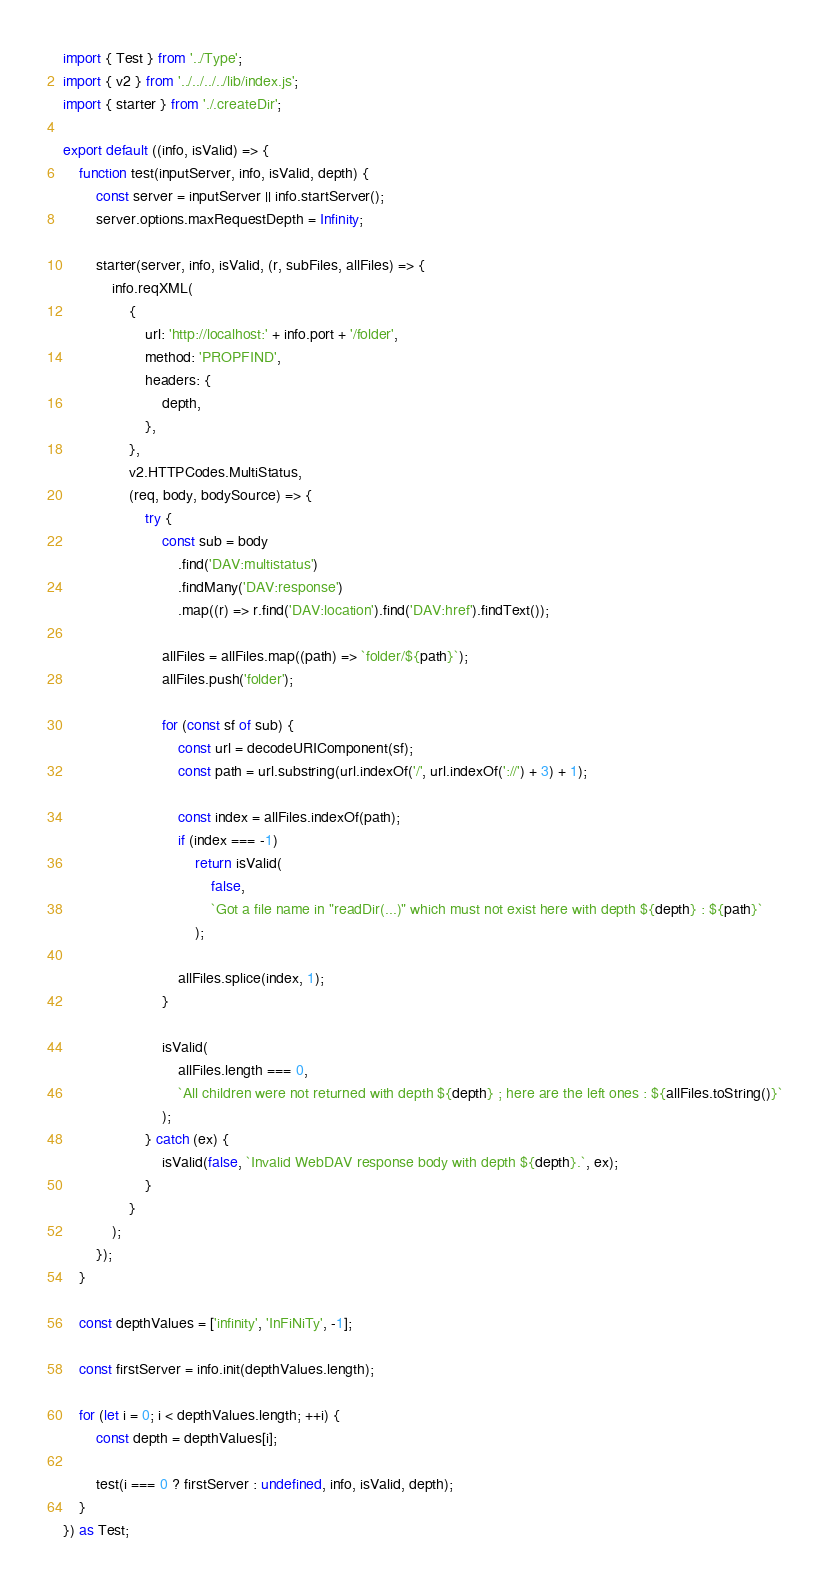Convert code to text. <code><loc_0><loc_0><loc_500><loc_500><_TypeScript_>import { Test } from '../Type';
import { v2 } from '../../../../lib/index.js';
import { starter } from './.createDir';

export default ((info, isValid) => {
	function test(inputServer, info, isValid, depth) {
		const server = inputServer || info.startServer();
		server.options.maxRequestDepth = Infinity;

		starter(server, info, isValid, (r, subFiles, allFiles) => {
			info.reqXML(
				{
					url: 'http://localhost:' + info.port + '/folder',
					method: 'PROPFIND',
					headers: {
						depth,
					},
				},
				v2.HTTPCodes.MultiStatus,
				(req, body, bodySource) => {
					try {
						const sub = body
							.find('DAV:multistatus')
							.findMany('DAV:response')
							.map((r) => r.find('DAV:location').find('DAV:href').findText());

						allFiles = allFiles.map((path) => `folder/${path}`);
						allFiles.push('folder');

						for (const sf of sub) {
							const url = decodeURIComponent(sf);
							const path = url.substring(url.indexOf('/', url.indexOf('://') + 3) + 1);

							const index = allFiles.indexOf(path);
							if (index === -1)
								return isValid(
									false,
									`Got a file name in "readDir(...)" which must not exist here with depth ${depth} : ${path}`
								);

							allFiles.splice(index, 1);
						}

						isValid(
							allFiles.length === 0,
							`All children were not returned with depth ${depth} ; here are the left ones : ${allFiles.toString()}`
						);
					} catch (ex) {
						isValid(false, `Invalid WebDAV response body with depth ${depth}.`, ex);
					}
				}
			);
		});
	}

	const depthValues = ['infinity', 'InFiNiTy', -1];

	const firstServer = info.init(depthValues.length);

	for (let i = 0; i < depthValues.length; ++i) {
		const depth = depthValues[i];

		test(i === 0 ? firstServer : undefined, info, isValid, depth);
	}
}) as Test;
</code> 